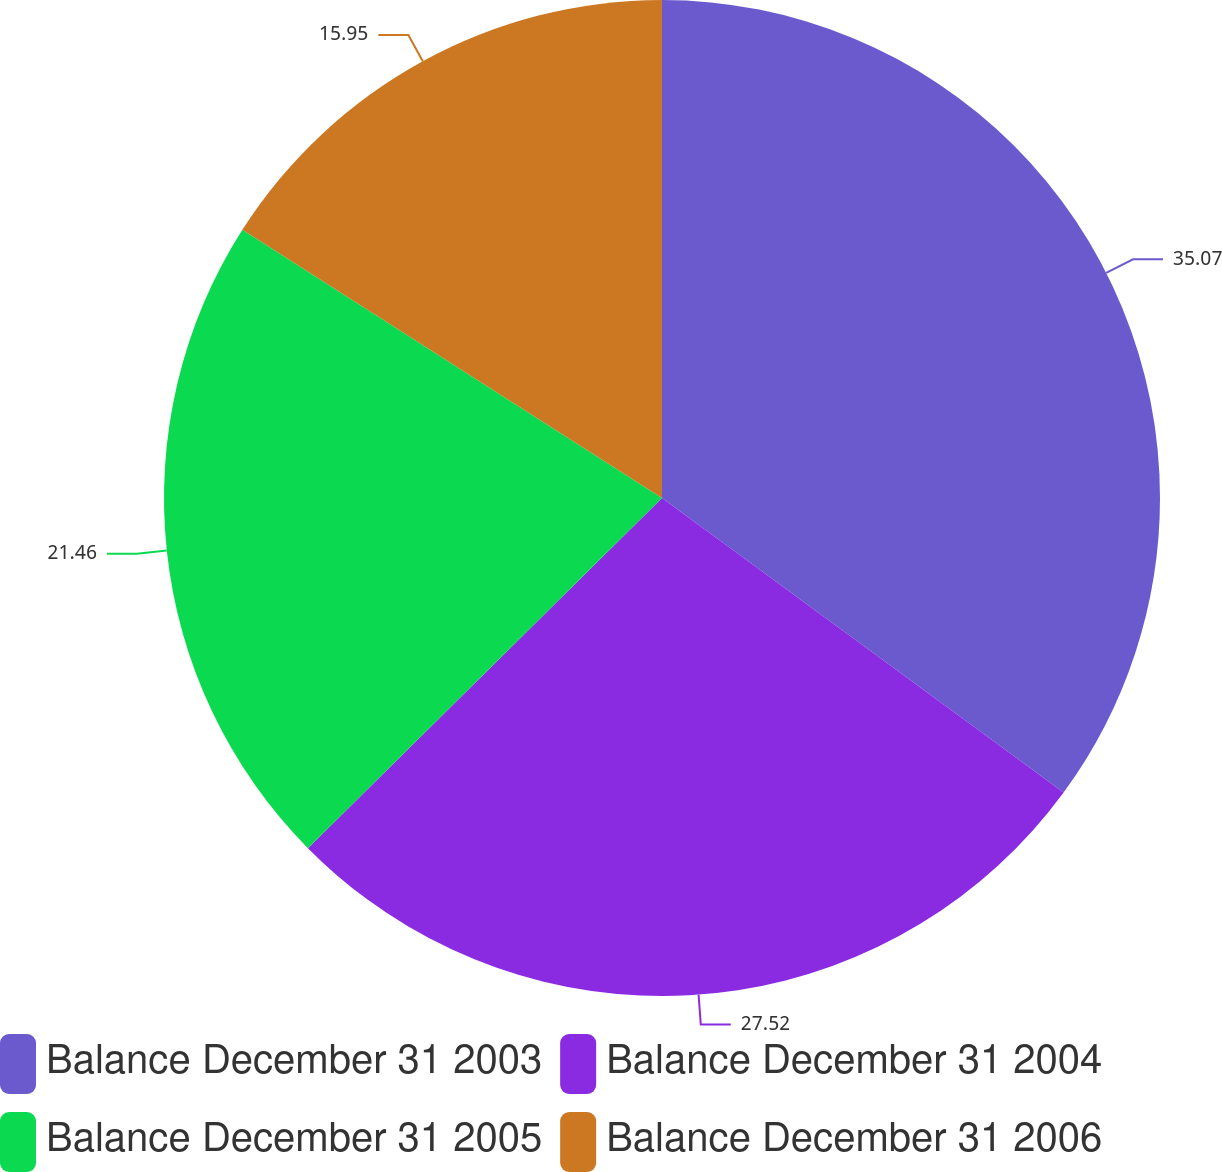<chart> <loc_0><loc_0><loc_500><loc_500><pie_chart><fcel>Balance December 31 2003<fcel>Balance December 31 2004<fcel>Balance December 31 2005<fcel>Balance December 31 2006<nl><fcel>35.07%<fcel>27.52%<fcel>21.46%<fcel>15.95%<nl></chart> 